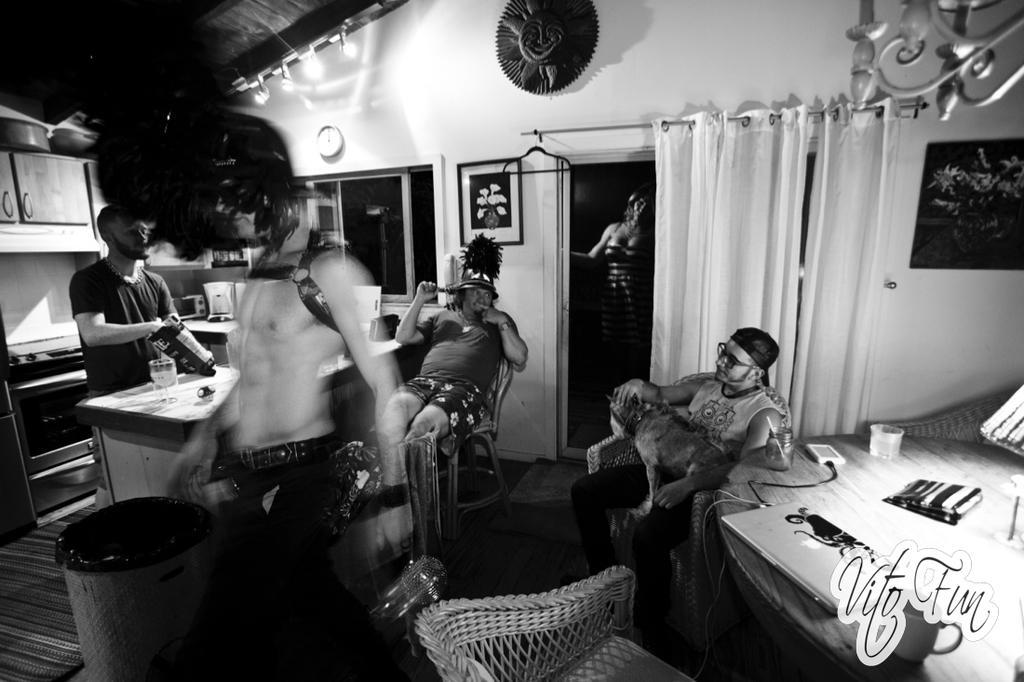Can you describe this image briefly? In this image there are five persons. On the table there is a laptop,cup. The person is sitting on the chair and holding a dog. There is a bin on the floor. 